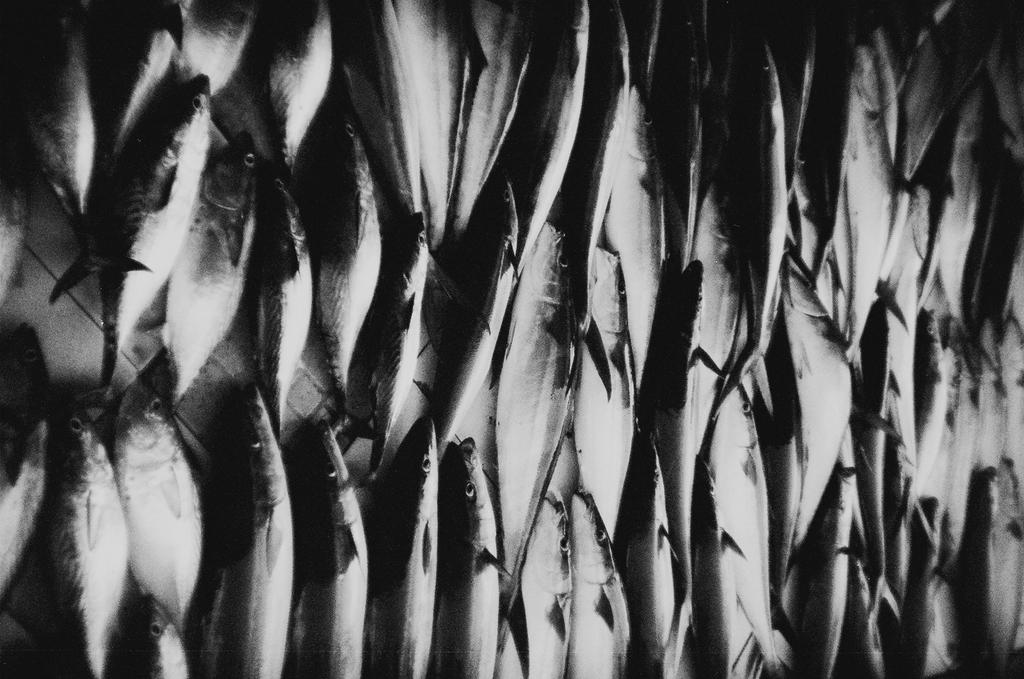What is the focus of the image? The image is zoomed in, so it is difficult to determine the entire scene. However, there are many fishes visible. What is the position of the fishes in the image? The fishes appear to be placed on the ground. What type of soda can be seen in the image? There is no soda present in the image; it features many fishes placed on the ground. Can you tell me how many babies are visible in the image? There are no babies present in the image; it features many fishes placed on the ground. 